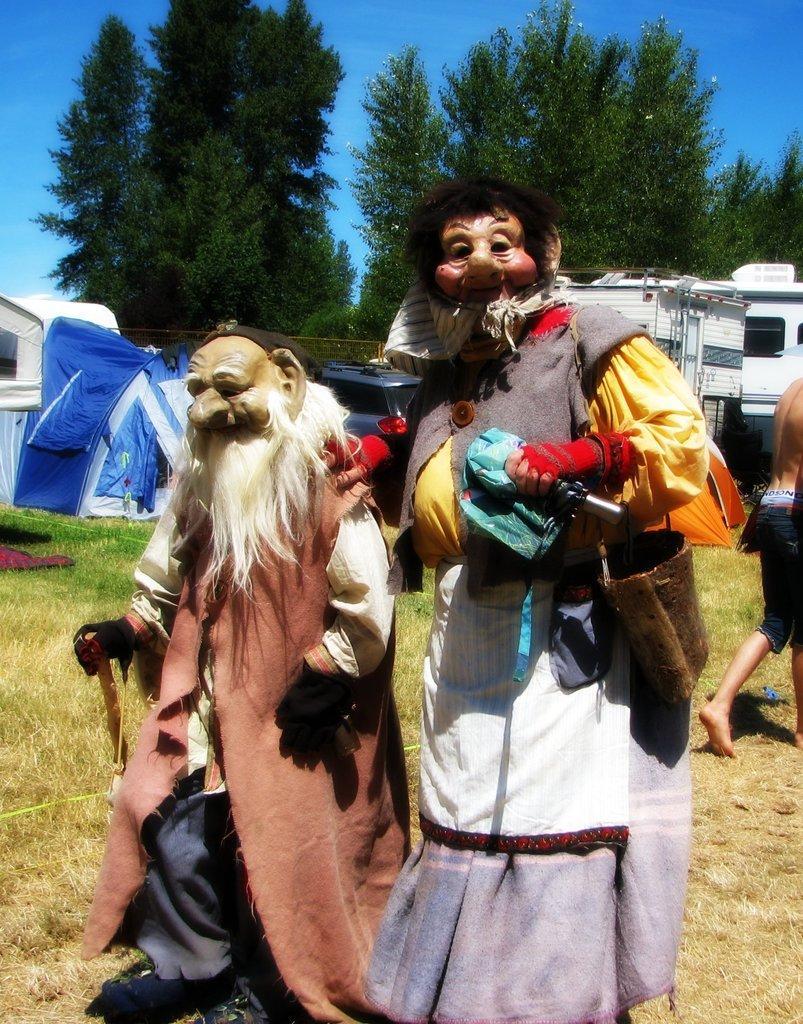In one or two sentences, can you explain what this image depicts? In the image there are two people wearing some cartoon costumes and behind them there is a person on the right side, they are on the grass surface and in the background there is a tent and few vehicles, behind the vehicles there are trees. 